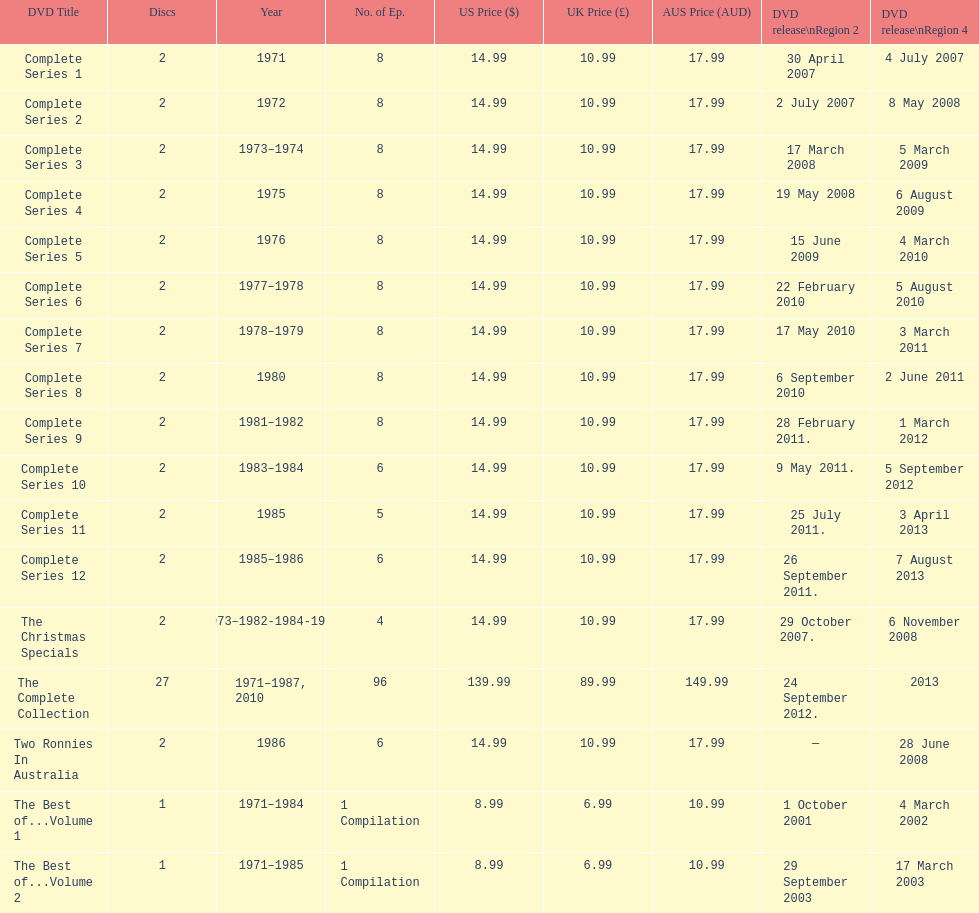The television show "the two ronnies" ran for a total of how many seasons? 12. 